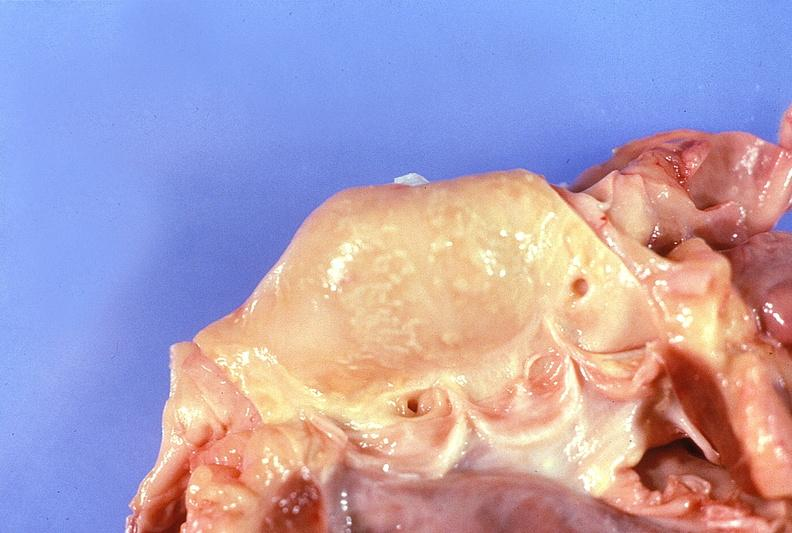does this image show normal aortic valve?
Answer the question using a single word or phrase. Yes 